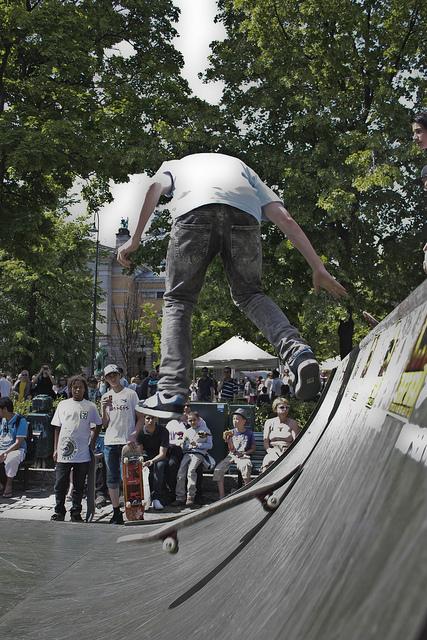Do the trees have green foliage?
Answer briefly. Yes. Are this person's feet planted on the skateboard?
Write a very short answer. No. Why is everyone standing around watching this guy?
Quick response, please. Skateboarding. 